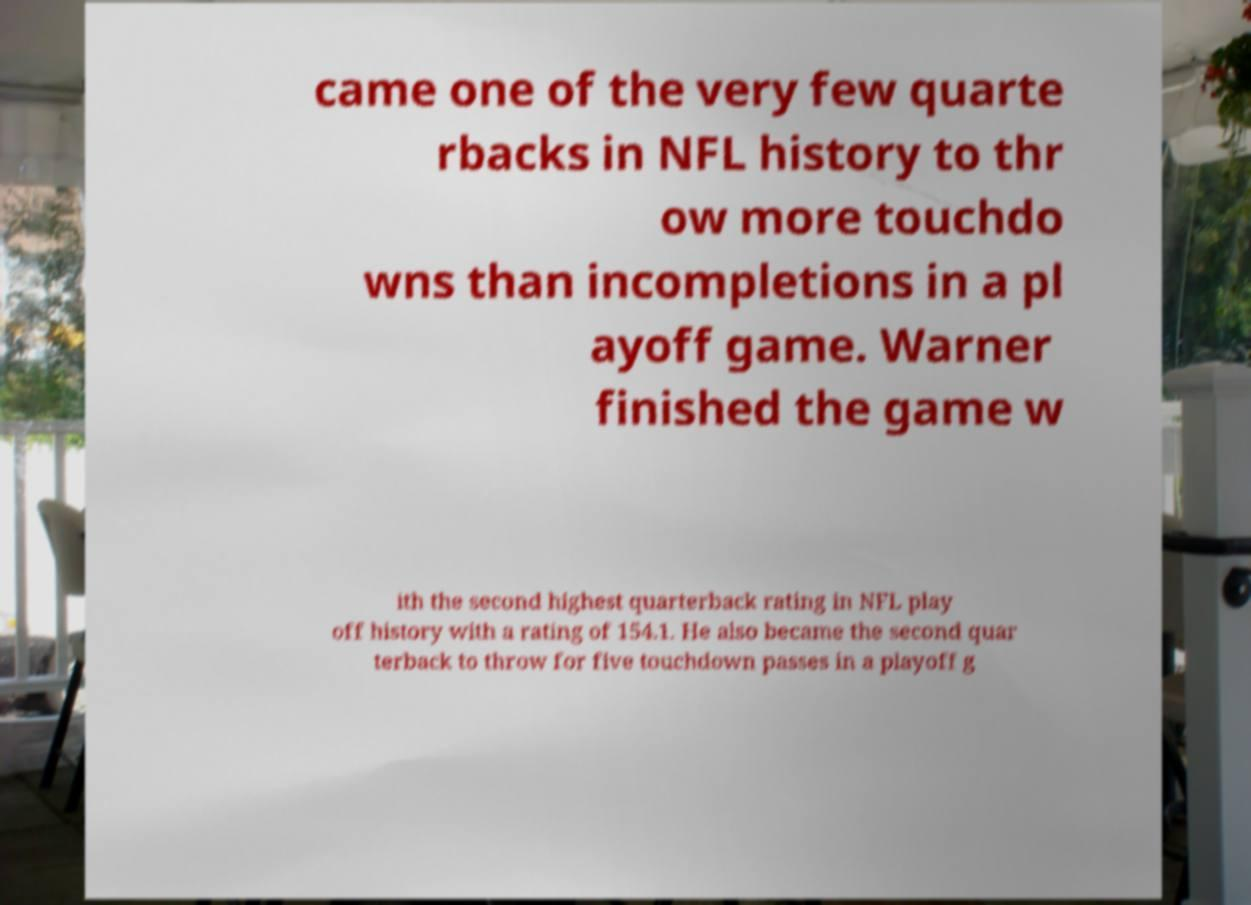There's text embedded in this image that I need extracted. Can you transcribe it verbatim? came one of the very few quarte rbacks in NFL history to thr ow more touchdo wns than incompletions in a pl ayoff game. Warner finished the game w ith the second highest quarterback rating in NFL play off history with a rating of 154.1. He also became the second quar terback to throw for five touchdown passes in a playoff g 